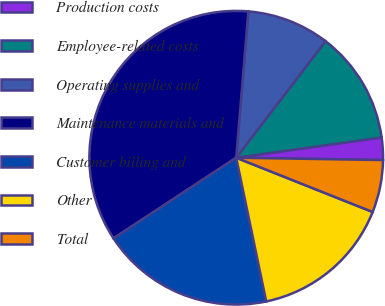Convert chart to OTSL. <chart><loc_0><loc_0><loc_500><loc_500><pie_chart><fcel>Production costs<fcel>Employee-related costs<fcel>Operating supplies and<fcel>Maintenance materials and<fcel>Customer billing and<fcel>Other<fcel>Total<nl><fcel>2.46%<fcel>12.39%<fcel>9.08%<fcel>35.57%<fcel>19.02%<fcel>15.7%<fcel>5.77%<nl></chart> 